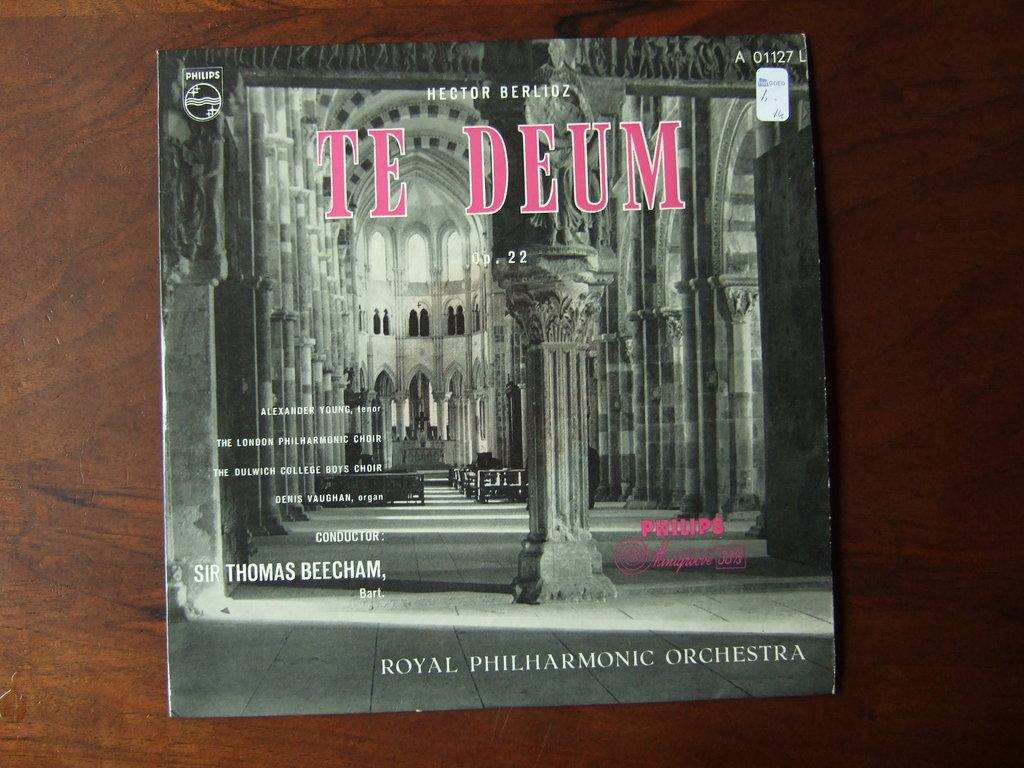<image>
Write a terse but informative summary of the picture. A vinyl record of the Royal Philharmonic Orchestra performing Te Deum. 